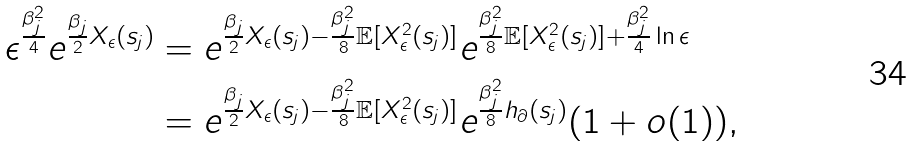Convert formula to latex. <formula><loc_0><loc_0><loc_500><loc_500>\epsilon ^ { \frac { \beta _ { j } ^ { 2 } } { 4 } } e ^ { \frac { \beta _ { j } } { 2 } X _ { \epsilon } ( s _ { j } ) } & = e ^ { \frac { \beta _ { j } } { 2 } X _ { \epsilon } ( s _ { j } ) - \frac { \beta _ { j } ^ { 2 } } { 8 } \mathbb { E } [ X _ { \epsilon } ^ { 2 } ( s _ { j } ) ] } e ^ { \frac { \beta _ { j } ^ { 2 } } { 8 } \mathbb { E } [ X _ { \epsilon } ^ { 2 } ( s _ { j } ) ] + \frac { \beta _ { j } ^ { 2 } } { 4 } \ln \epsilon } \\ & = e ^ { \frac { \beta _ { j } } { 2 } X _ { \epsilon } ( s _ { j } ) - \frac { \beta _ { j } ^ { 2 } } { 8 } \mathbb { E } [ X _ { \epsilon } ^ { 2 } ( s _ { j } ) ] } e ^ { \frac { \beta _ { j } ^ { 2 } } { 8 } h _ { \partial } ( s _ { j } ) } ( 1 + o ( 1 ) ) ,</formula> 